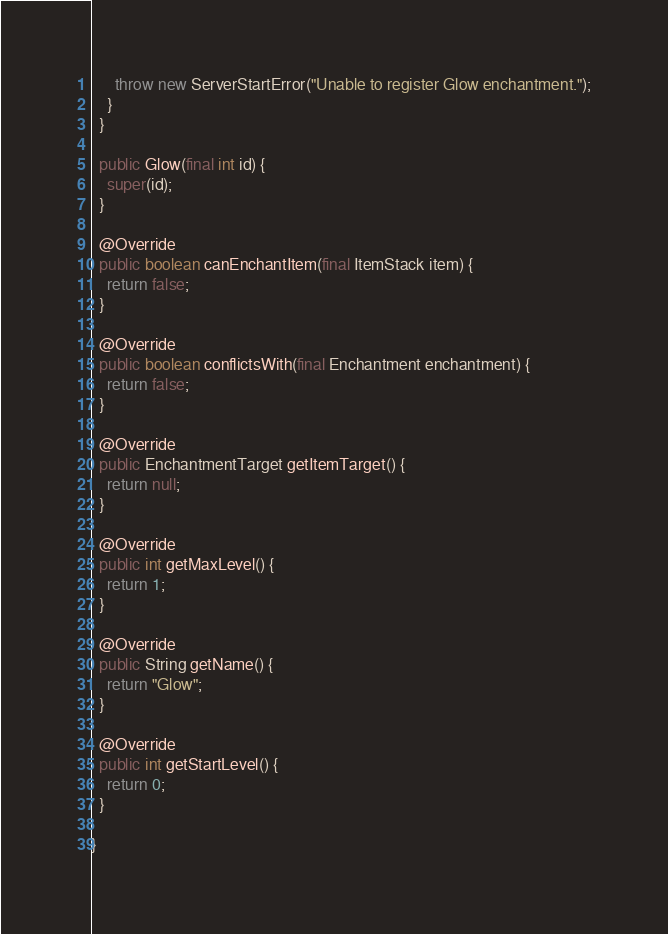<code> <loc_0><loc_0><loc_500><loc_500><_Java_>      throw new ServerStartError("Unable to register Glow enchantment.");
    }
  }

  public Glow(final int id) {
    super(id);
  }

  @Override
  public boolean canEnchantItem(final ItemStack item) {
    return false;
  }

  @Override
  public boolean conflictsWith(final Enchantment enchantment) {
    return false;
  }

  @Override
  public EnchantmentTarget getItemTarget() {
    return null;
  }

  @Override
  public int getMaxLevel() {
    return 1;
  }

  @Override
  public String getName() {
    return "Glow";
  }

  @Override
  public int getStartLevel() {
    return 0;
  }

}
</code> 